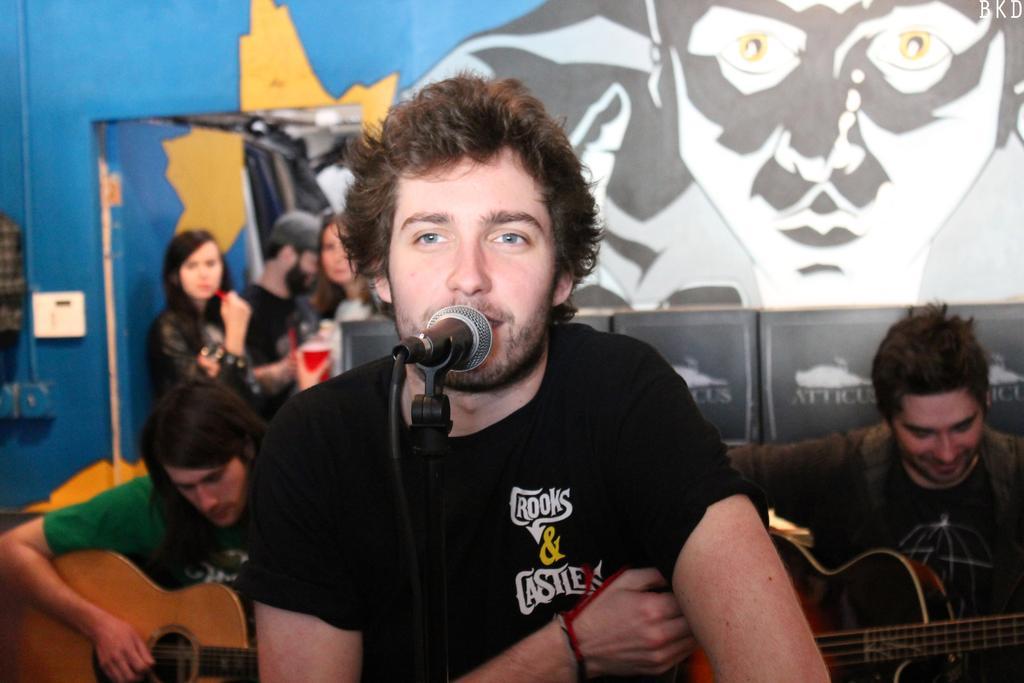Could you give a brief overview of what you see in this image? In this image I see 3 men, in which 2 of them are holding the guitar and one of them is front of the pic. In the background I see the wall and 3 persons. 